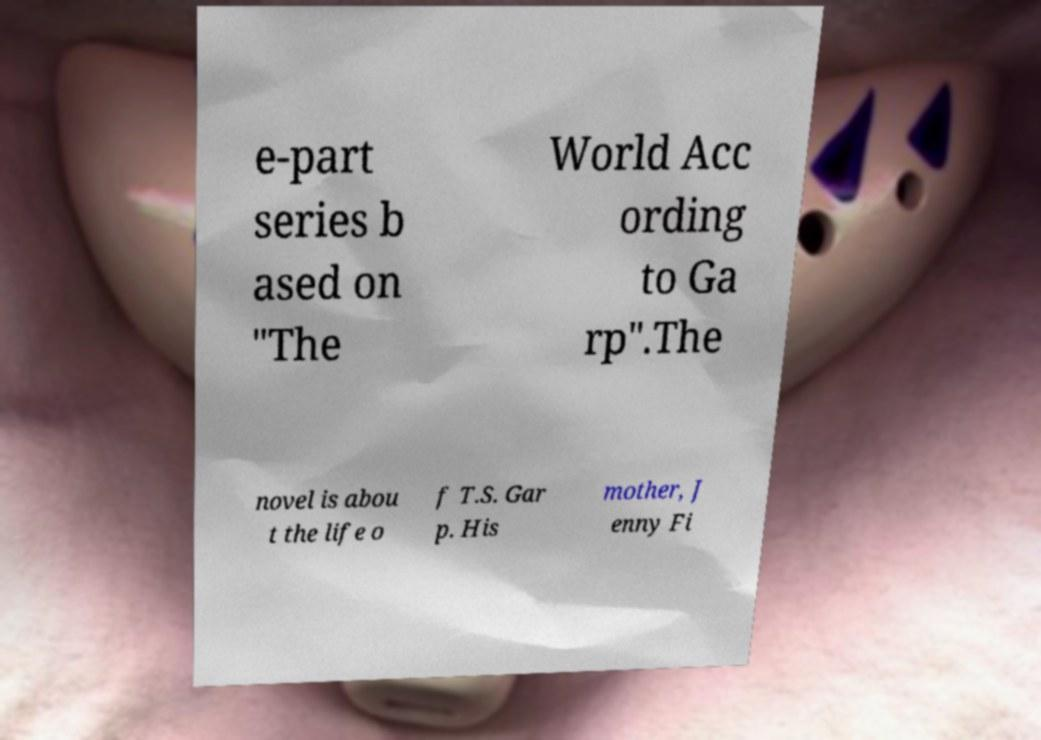Please identify and transcribe the text found in this image. e-part series b ased on "The World Acc ording to Ga rp".The novel is abou t the life o f T.S. Gar p. His mother, J enny Fi 